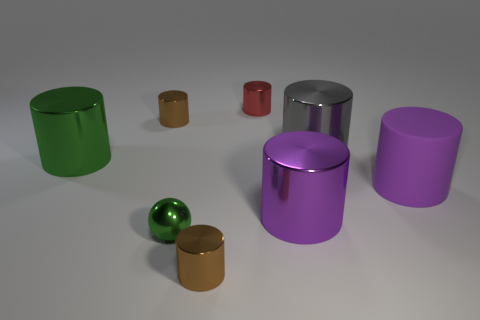Subtract all brown balls. How many brown cylinders are left? 2 Subtract all tiny brown cylinders. How many cylinders are left? 5 Subtract all purple cylinders. How many cylinders are left? 5 Add 2 tiny gray metal things. How many objects exist? 10 Subtract all purple cylinders. Subtract all blue blocks. How many cylinders are left? 5 Subtract all balls. How many objects are left? 7 Add 7 large gray matte blocks. How many large gray matte blocks exist? 7 Subtract 0 green cubes. How many objects are left? 8 Subtract all small yellow shiny cubes. Subtract all tiny brown cylinders. How many objects are left? 6 Add 7 matte objects. How many matte objects are left? 8 